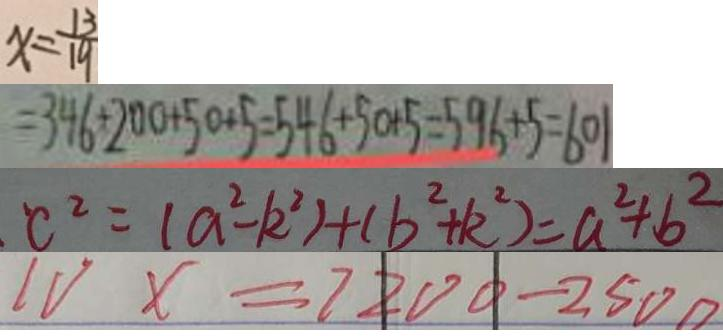<formula> <loc_0><loc_0><loc_500><loc_500>x = \frac { 1 3 } { 1 9 } 
 = 3 4 6 + 2 0 0 + 5 0 + 5 = 5 4 6 + 5 0 + 5 = 5 9 6 + 5 = 6 0 1 
 c ^ { 2 } = ( a ^ { 2 } - k ^ { 2 } ) + ( b ^ { 2 } + k ^ { 2 } ) = a ^ { 2 } + b ^ { 2 } 
 1 v x = 7 2 0 0 - 2 5 0 0</formula> 